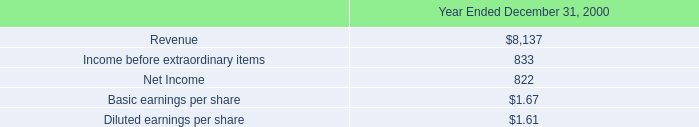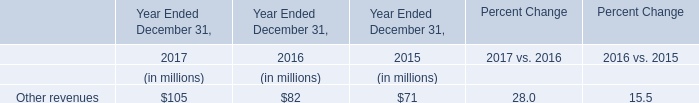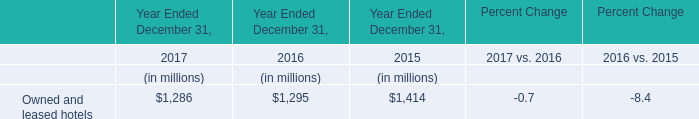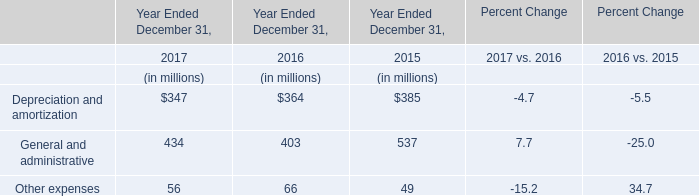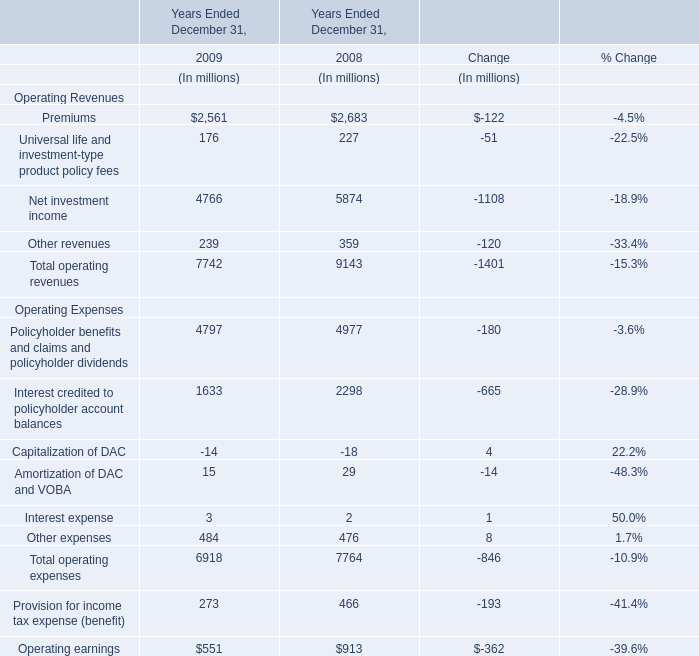What's the growth rate of Other revenues in 2009 ended December 31? 
Computations: ((239 - 359) / 359)
Answer: -0.33426. 